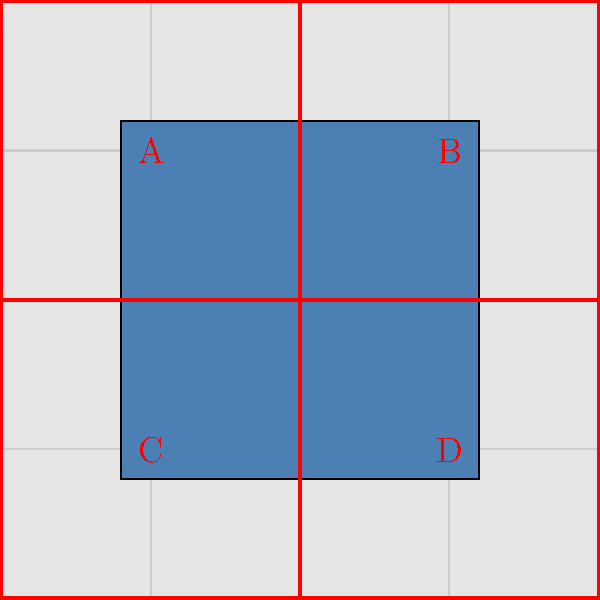In creating seamless textures for tiling in game environments, which quadrant(s) of the texture need to be adjusted to ensure perfect tiling when the texture is repeated? To create a seamless texture for tiling in game environments, we need to understand the concept of edge matching. The process involves the following steps:

1. Divide the texture into four quadrants: A, B, C, and D, as shown in the diagram.

2. The main issue in tiling arises from the edges of the texture. When tiled, the right edge needs to match the left edge, and the top edge needs to match the bottom edge.

3. Quadrant A affects the top-left corner, B the top-right, C the bottom-left, and D the bottom-right.

4. The critical areas for seamless tiling are:
   - The right edge of A and C, which should match the left edge of B and D respectively.
   - The bottom edge of A and B, which should match the top edge of C and D respectively.

5. However, simply adjusting these edges is not enough. The corners where these edges meet are crucial for perfect tiling.

6. The corner where A, B, C, and D meet is the most critical point. This single point will appear in all four corners of the tiled texture when repeated.

7. Therefore, to ensure perfect tiling, we need to adjust all four quadrants (A, B, C, and D) to make sure that this central point and all edges align seamlessly.

8. Techniques like mirroring, cloning, or using specialized tools in image editing software can be employed to achieve this seamless effect across all quadrants.

By adjusting all four quadrants, we ensure that the texture tiles perfectly in all directions, creating a seamless and immersive environment in the game.
Answer: All quadrants (A, B, C, and D) 